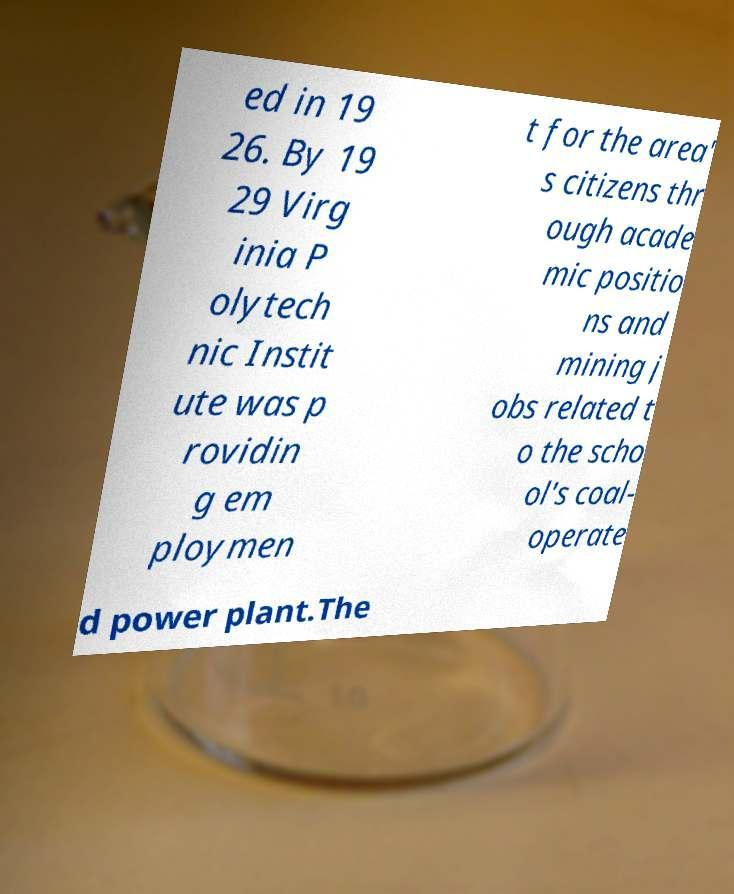For documentation purposes, I need the text within this image transcribed. Could you provide that? ed in 19 26. By 19 29 Virg inia P olytech nic Instit ute was p rovidin g em ploymen t for the area' s citizens thr ough acade mic positio ns and mining j obs related t o the scho ol's coal- operate d power plant.The 